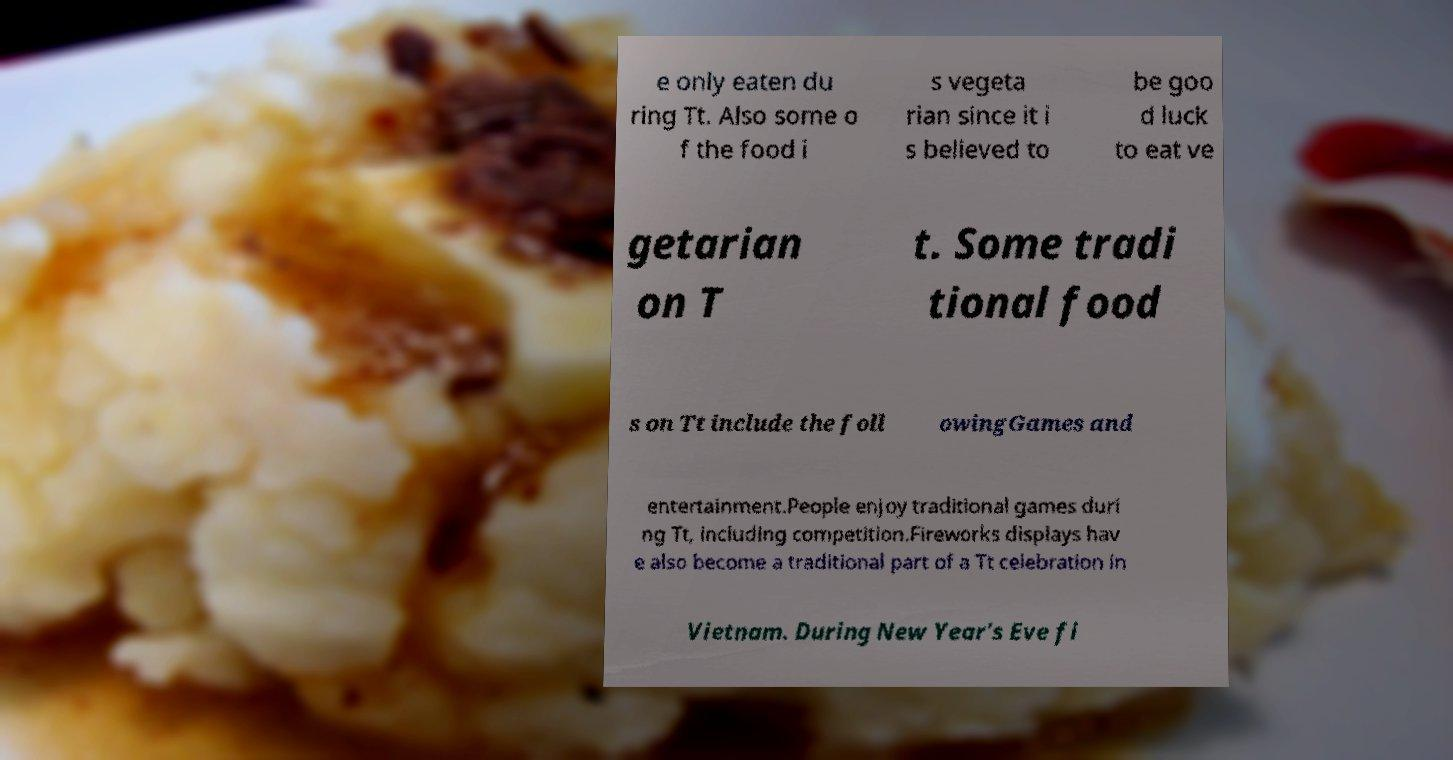Can you accurately transcribe the text from the provided image for me? e only eaten du ring Tt. Also some o f the food i s vegeta rian since it i s believed to be goo d luck to eat ve getarian on T t. Some tradi tional food s on Tt include the foll owingGames and entertainment.People enjoy traditional games duri ng Tt, including competition.Fireworks displays hav e also become a traditional part of a Tt celebration in Vietnam. During New Year's Eve fi 